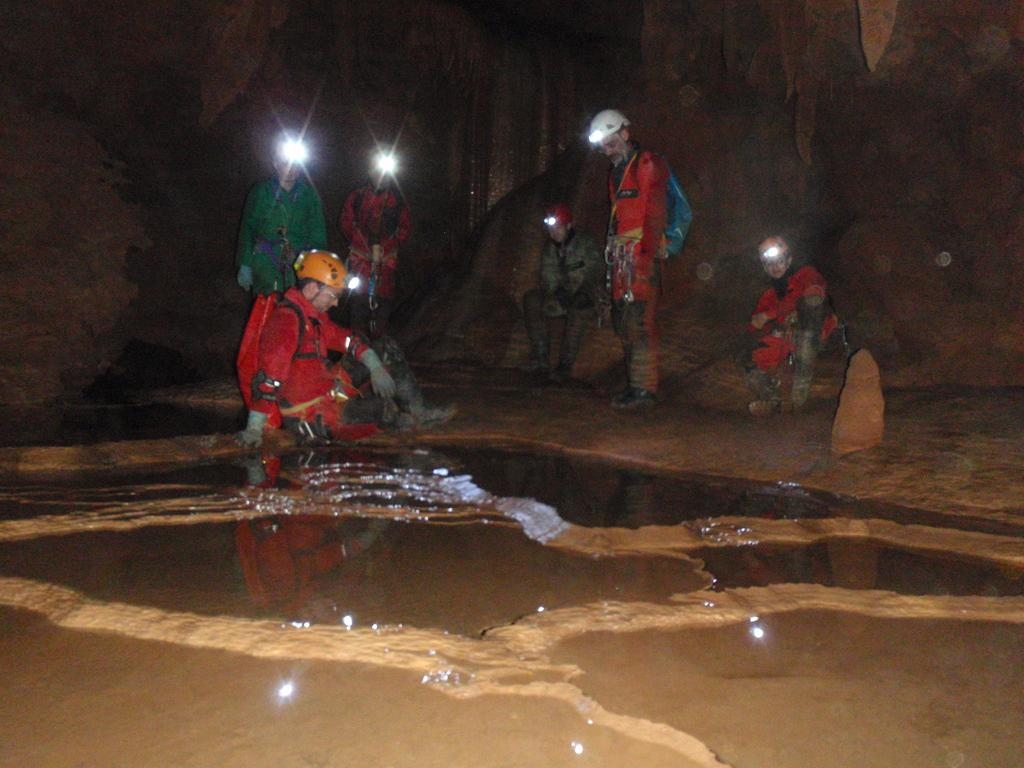How many people are in the image? There are people in the image, but the exact number is not specified. What are the people doing in the image? The people are sitting and standing in the image. What protective gear are the people wearing? The people are wearing safety helmets with headlamps in the image. What can be seen at the bottom of the image? There is water at the bottom of the image. What type of natural feature is visible in the background? There are rocks in the background of the image. What type of tin can be seen in the image? There is no tin present in the image. How many shades of color can be seen on the rocks in the background? The facts do not mention the colors of the rocks, so we cannot determine the number of shades in the image. 